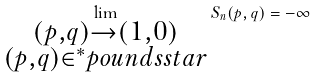<formula> <loc_0><loc_0><loc_500><loc_500>\lim _ { \substack { ( p , q ) \to ( 1 , 0 ) \\ ( p , q ) \in ^ { * } p o u n d s s t a r } } S _ { n } ( p , q ) = - \infty</formula> 